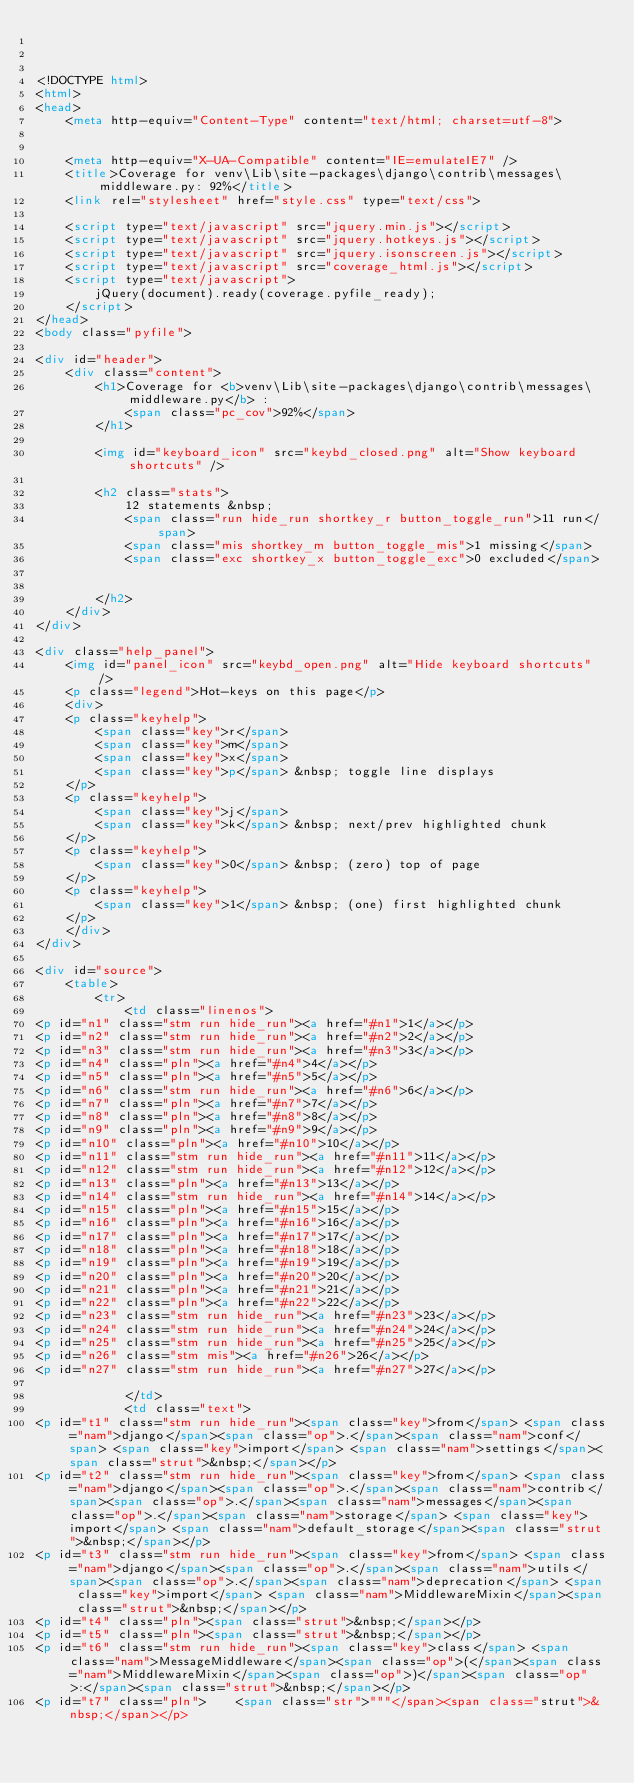<code> <loc_0><loc_0><loc_500><loc_500><_HTML_>


<!DOCTYPE html>
<html>
<head>
    <meta http-equiv="Content-Type" content="text/html; charset=utf-8">
    
    
    <meta http-equiv="X-UA-Compatible" content="IE=emulateIE7" />
    <title>Coverage for venv\Lib\site-packages\django\contrib\messages\middleware.py: 92%</title>
    <link rel="stylesheet" href="style.css" type="text/css">
    
    <script type="text/javascript" src="jquery.min.js"></script>
    <script type="text/javascript" src="jquery.hotkeys.js"></script>
    <script type="text/javascript" src="jquery.isonscreen.js"></script>
    <script type="text/javascript" src="coverage_html.js"></script>
    <script type="text/javascript">
        jQuery(document).ready(coverage.pyfile_ready);
    </script>
</head>
<body class="pyfile">

<div id="header">
    <div class="content">
        <h1>Coverage for <b>venv\Lib\site-packages\django\contrib\messages\middleware.py</b> :
            <span class="pc_cov">92%</span>
        </h1>

        <img id="keyboard_icon" src="keybd_closed.png" alt="Show keyboard shortcuts" />

        <h2 class="stats">
            12 statements &nbsp;
            <span class="run hide_run shortkey_r button_toggle_run">11 run</span>
            <span class="mis shortkey_m button_toggle_mis">1 missing</span>
            <span class="exc shortkey_x button_toggle_exc">0 excluded</span>

            
        </h2>
    </div>
</div>

<div class="help_panel">
    <img id="panel_icon" src="keybd_open.png" alt="Hide keyboard shortcuts" />
    <p class="legend">Hot-keys on this page</p>
    <div>
    <p class="keyhelp">
        <span class="key">r</span>
        <span class="key">m</span>
        <span class="key">x</span>
        <span class="key">p</span> &nbsp; toggle line displays
    </p>
    <p class="keyhelp">
        <span class="key">j</span>
        <span class="key">k</span> &nbsp; next/prev highlighted chunk
    </p>
    <p class="keyhelp">
        <span class="key">0</span> &nbsp; (zero) top of page
    </p>
    <p class="keyhelp">
        <span class="key">1</span> &nbsp; (one) first highlighted chunk
    </p>
    </div>
</div>

<div id="source">
    <table>
        <tr>
            <td class="linenos">
<p id="n1" class="stm run hide_run"><a href="#n1">1</a></p>
<p id="n2" class="stm run hide_run"><a href="#n2">2</a></p>
<p id="n3" class="stm run hide_run"><a href="#n3">3</a></p>
<p id="n4" class="pln"><a href="#n4">4</a></p>
<p id="n5" class="pln"><a href="#n5">5</a></p>
<p id="n6" class="stm run hide_run"><a href="#n6">6</a></p>
<p id="n7" class="pln"><a href="#n7">7</a></p>
<p id="n8" class="pln"><a href="#n8">8</a></p>
<p id="n9" class="pln"><a href="#n9">9</a></p>
<p id="n10" class="pln"><a href="#n10">10</a></p>
<p id="n11" class="stm run hide_run"><a href="#n11">11</a></p>
<p id="n12" class="stm run hide_run"><a href="#n12">12</a></p>
<p id="n13" class="pln"><a href="#n13">13</a></p>
<p id="n14" class="stm run hide_run"><a href="#n14">14</a></p>
<p id="n15" class="pln"><a href="#n15">15</a></p>
<p id="n16" class="pln"><a href="#n16">16</a></p>
<p id="n17" class="pln"><a href="#n17">17</a></p>
<p id="n18" class="pln"><a href="#n18">18</a></p>
<p id="n19" class="pln"><a href="#n19">19</a></p>
<p id="n20" class="pln"><a href="#n20">20</a></p>
<p id="n21" class="pln"><a href="#n21">21</a></p>
<p id="n22" class="pln"><a href="#n22">22</a></p>
<p id="n23" class="stm run hide_run"><a href="#n23">23</a></p>
<p id="n24" class="stm run hide_run"><a href="#n24">24</a></p>
<p id="n25" class="stm run hide_run"><a href="#n25">25</a></p>
<p id="n26" class="stm mis"><a href="#n26">26</a></p>
<p id="n27" class="stm run hide_run"><a href="#n27">27</a></p>

            </td>
            <td class="text">
<p id="t1" class="stm run hide_run"><span class="key">from</span> <span class="nam">django</span><span class="op">.</span><span class="nam">conf</span> <span class="key">import</span> <span class="nam">settings</span><span class="strut">&nbsp;</span></p>
<p id="t2" class="stm run hide_run"><span class="key">from</span> <span class="nam">django</span><span class="op">.</span><span class="nam">contrib</span><span class="op">.</span><span class="nam">messages</span><span class="op">.</span><span class="nam">storage</span> <span class="key">import</span> <span class="nam">default_storage</span><span class="strut">&nbsp;</span></p>
<p id="t3" class="stm run hide_run"><span class="key">from</span> <span class="nam">django</span><span class="op">.</span><span class="nam">utils</span><span class="op">.</span><span class="nam">deprecation</span> <span class="key">import</span> <span class="nam">MiddlewareMixin</span><span class="strut">&nbsp;</span></p>
<p id="t4" class="pln"><span class="strut">&nbsp;</span></p>
<p id="t5" class="pln"><span class="strut">&nbsp;</span></p>
<p id="t6" class="stm run hide_run"><span class="key">class</span> <span class="nam">MessageMiddleware</span><span class="op">(</span><span class="nam">MiddlewareMixin</span><span class="op">)</span><span class="op">:</span><span class="strut">&nbsp;</span></p>
<p id="t7" class="pln">    <span class="str">"""</span><span class="strut">&nbsp;</span></p></code> 